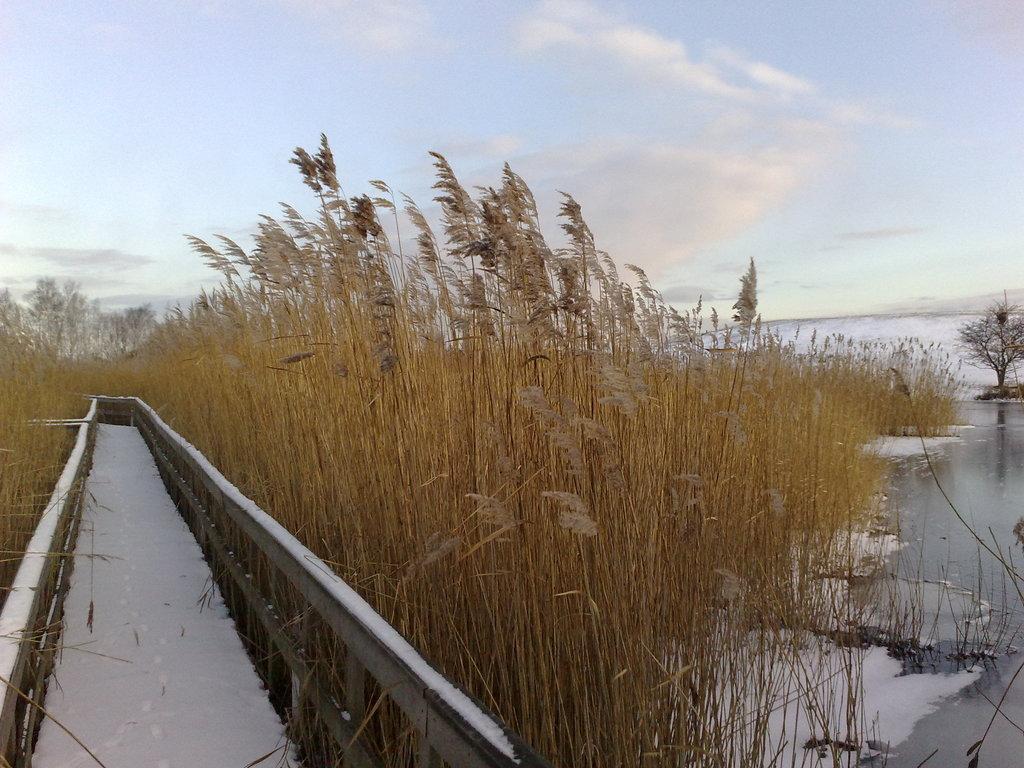Please provide a concise description of this image. In this image, we can see a path in between plants. There is a lake on the right side of the image. In the background of the image, there is a sky. 